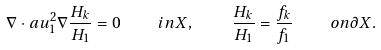Convert formula to latex. <formula><loc_0><loc_0><loc_500><loc_500>\nabla \cdot a u _ { 1 } ^ { 2 } \nabla \frac { H _ { k } } { H _ { 1 } } = 0 \quad i n X , \quad \frac { H _ { k } } { H _ { 1 } } = \frac { f _ { k } } { f _ { 1 } } \quad o n \partial X .</formula> 